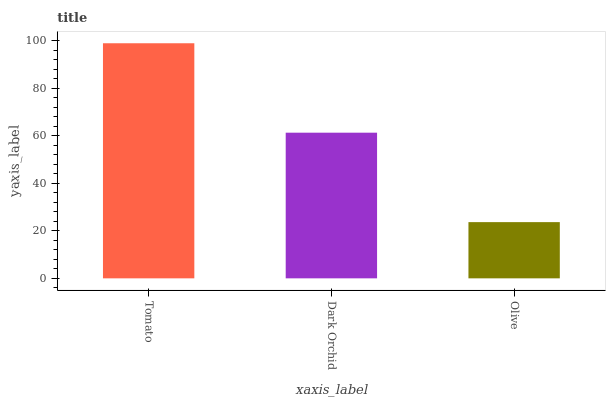Is Olive the minimum?
Answer yes or no. Yes. Is Tomato the maximum?
Answer yes or no. Yes. Is Dark Orchid the minimum?
Answer yes or no. No. Is Dark Orchid the maximum?
Answer yes or no. No. Is Tomato greater than Dark Orchid?
Answer yes or no. Yes. Is Dark Orchid less than Tomato?
Answer yes or no. Yes. Is Dark Orchid greater than Tomato?
Answer yes or no. No. Is Tomato less than Dark Orchid?
Answer yes or no. No. Is Dark Orchid the high median?
Answer yes or no. Yes. Is Dark Orchid the low median?
Answer yes or no. Yes. Is Olive the high median?
Answer yes or no. No. Is Olive the low median?
Answer yes or no. No. 